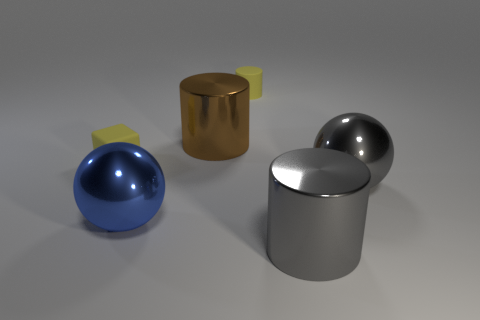There is a small rubber object that is the same color as the matte cylinder; what shape is it?
Offer a terse response. Cube. Is there a blue metal thing?
Provide a succinct answer. Yes. The brown cylinder that is the same material as the blue thing is what size?
Keep it short and to the point. Large. Are there any small objects that have the same color as the small matte cylinder?
Your answer should be very brief. Yes. There is a ball right of the big blue thing; is it the same color as the metallic cylinder to the right of the brown cylinder?
Provide a short and direct response. Yes. What is the size of the object that is the same color as the cube?
Make the answer very short. Small. Is there a big blue thing made of the same material as the large brown object?
Your response must be concise. Yes. The rubber block has what color?
Keep it short and to the point. Yellow. There is a metallic cylinder that is in front of the yellow thing on the left side of the large metallic cylinder behind the tiny yellow rubber block; how big is it?
Give a very brief answer. Large. What number of other objects are the same shape as the blue object?
Offer a very short reply. 1. 